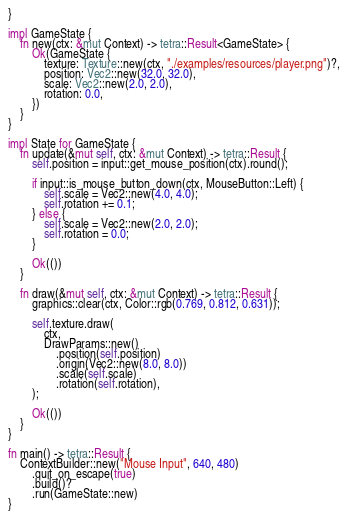<code> <loc_0><loc_0><loc_500><loc_500><_Rust_>}

impl GameState {
    fn new(ctx: &mut Context) -> tetra::Result<GameState> {
        Ok(GameState {
            texture: Texture::new(ctx, "./examples/resources/player.png")?,
            position: Vec2::new(32.0, 32.0),
            scale: Vec2::new(2.0, 2.0),
            rotation: 0.0,
        })
    }
}

impl State for GameState {
    fn update(&mut self, ctx: &mut Context) -> tetra::Result {
        self.position = input::get_mouse_position(ctx).round();

        if input::is_mouse_button_down(ctx, MouseButton::Left) {
            self.scale = Vec2::new(4.0, 4.0);
            self.rotation += 0.1;
        } else {
            self.scale = Vec2::new(2.0, 2.0);
            self.rotation = 0.0;
        }

        Ok(())
    }

    fn draw(&mut self, ctx: &mut Context) -> tetra::Result {
        graphics::clear(ctx, Color::rgb(0.769, 0.812, 0.631));

        self.texture.draw(
            ctx,
            DrawParams::new()
                .position(self.position)
                .origin(Vec2::new(8.0, 8.0))
                .scale(self.scale)
                .rotation(self.rotation),
        );

        Ok(())
    }
}

fn main() -> tetra::Result {
    ContextBuilder::new("Mouse Input", 640, 480)
        .quit_on_escape(true)
        .build()?
        .run(GameState::new)
}
</code> 